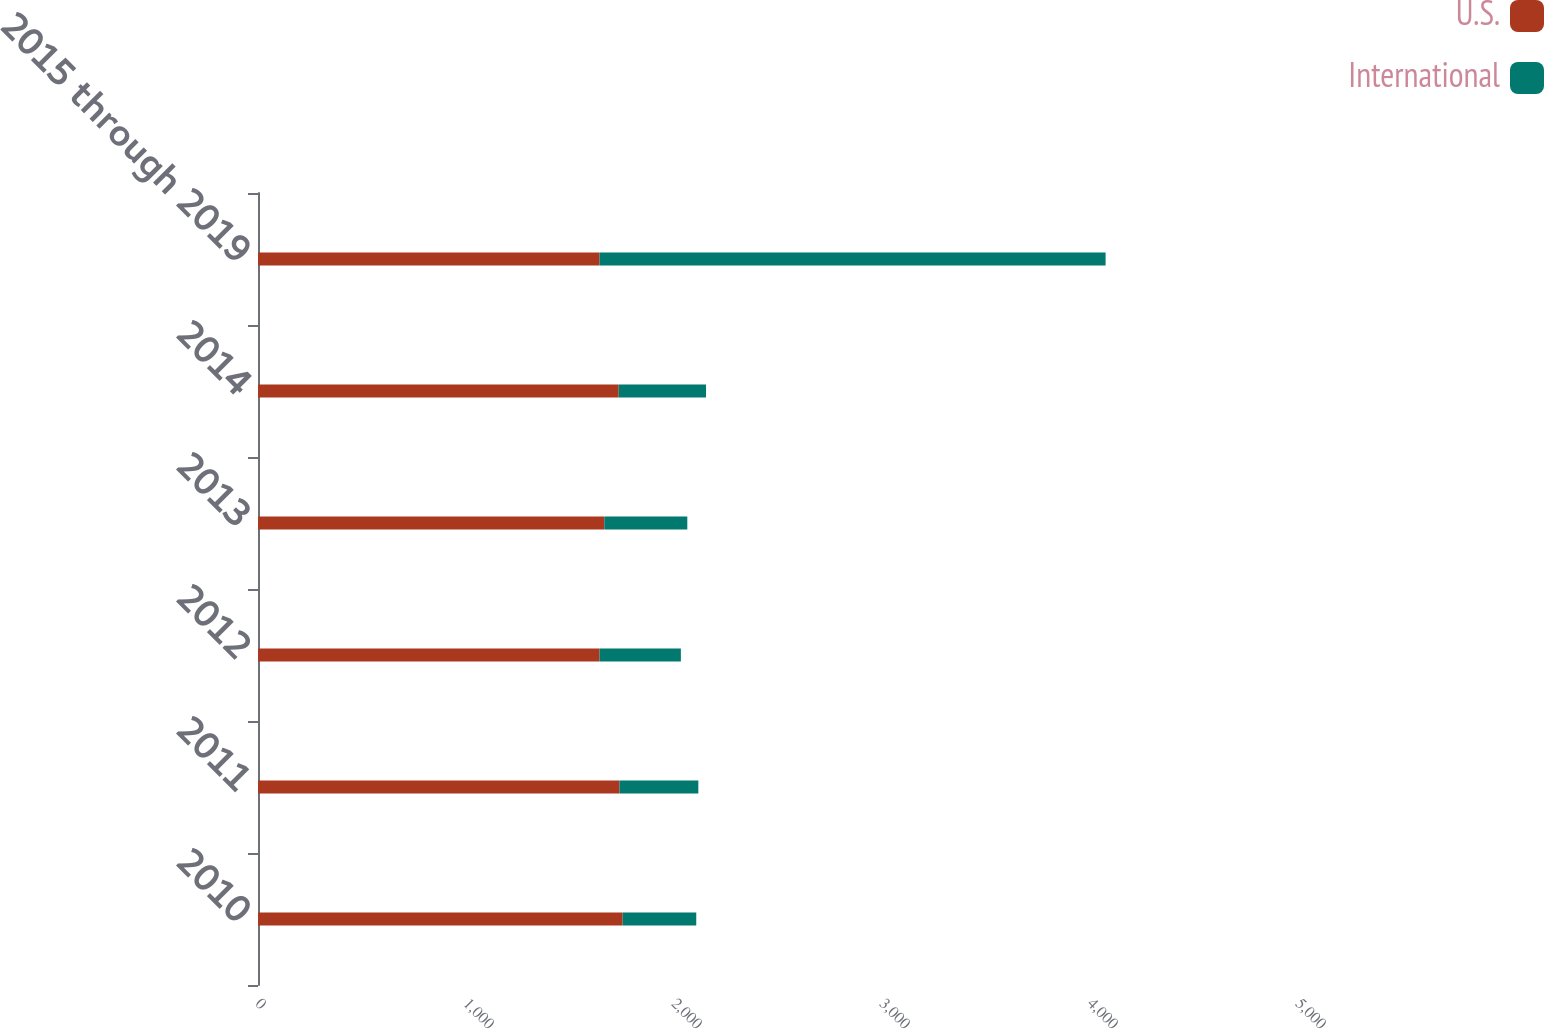<chart> <loc_0><loc_0><loc_500><loc_500><stacked_bar_chart><ecel><fcel>2010<fcel>2011<fcel>2012<fcel>2013<fcel>2014<fcel>2015 through 2019<nl><fcel>U.S.<fcel>1753<fcel>1738<fcel>1642<fcel>1665<fcel>1734<fcel>1642<nl><fcel>International<fcel>354<fcel>379<fcel>391<fcel>399<fcel>420<fcel>2433<nl></chart> 